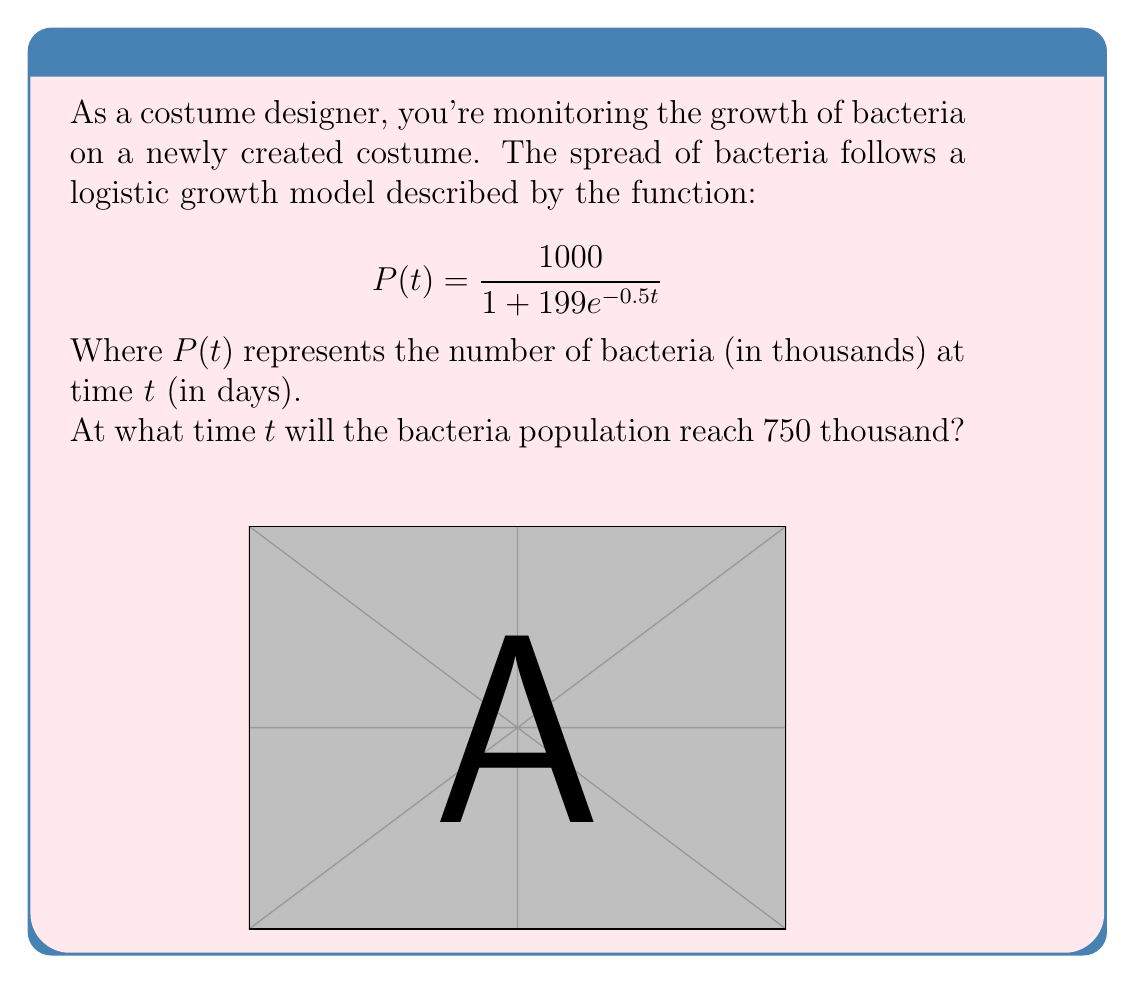Help me with this question. Let's solve this step-by-step:

1) We want to find $t$ when $P(t) = 750$. So, let's set up the equation:

   $$750 = \frac{1000}{1 + 199e^{-0.5t}}$$

2) Multiply both sides by $(1 + 199e^{-0.5t})$:

   $$750(1 + 199e^{-0.5t}) = 1000$$

3) Expand the left side:

   $$750 + 149250e^{-0.5t} = 1000$$

4) Subtract 750 from both sides:

   $$149250e^{-0.5t} = 250$$

5) Divide both sides by 149250:

   $$e^{-0.5t} = \frac{1}{597}$$

6) Take the natural log of both sides:

   $$-0.5t = \ln(\frac{1}{597})$$

7) Multiply both sides by -2:

   $$t = -2\ln(\frac{1}{597})$$

8) Simplify:

   $$t = 2\ln(597)$$

9) Calculate the value (rounded to 2 decimal places):

   $$t \approx 12.77$$

Therefore, the bacteria population will reach 750 thousand after approximately 12.77 days.
Answer: $2\ln(597) \approx 12.77$ days 